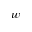Convert formula to latex. <formula><loc_0><loc_0><loc_500><loc_500>w</formula> 